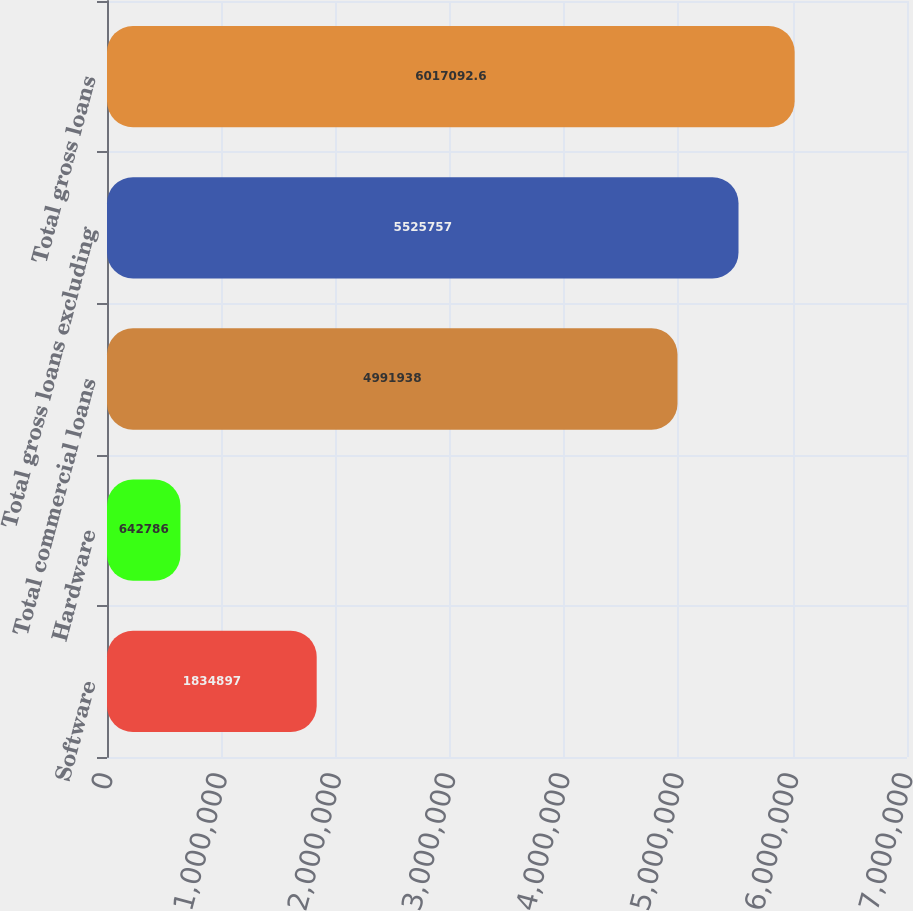<chart> <loc_0><loc_0><loc_500><loc_500><bar_chart><fcel>Software<fcel>Hardware<fcel>Total commercial loans<fcel>Total gross loans excluding<fcel>Total gross loans<nl><fcel>1.8349e+06<fcel>642786<fcel>4.99194e+06<fcel>5.52576e+06<fcel>6.01709e+06<nl></chart> 